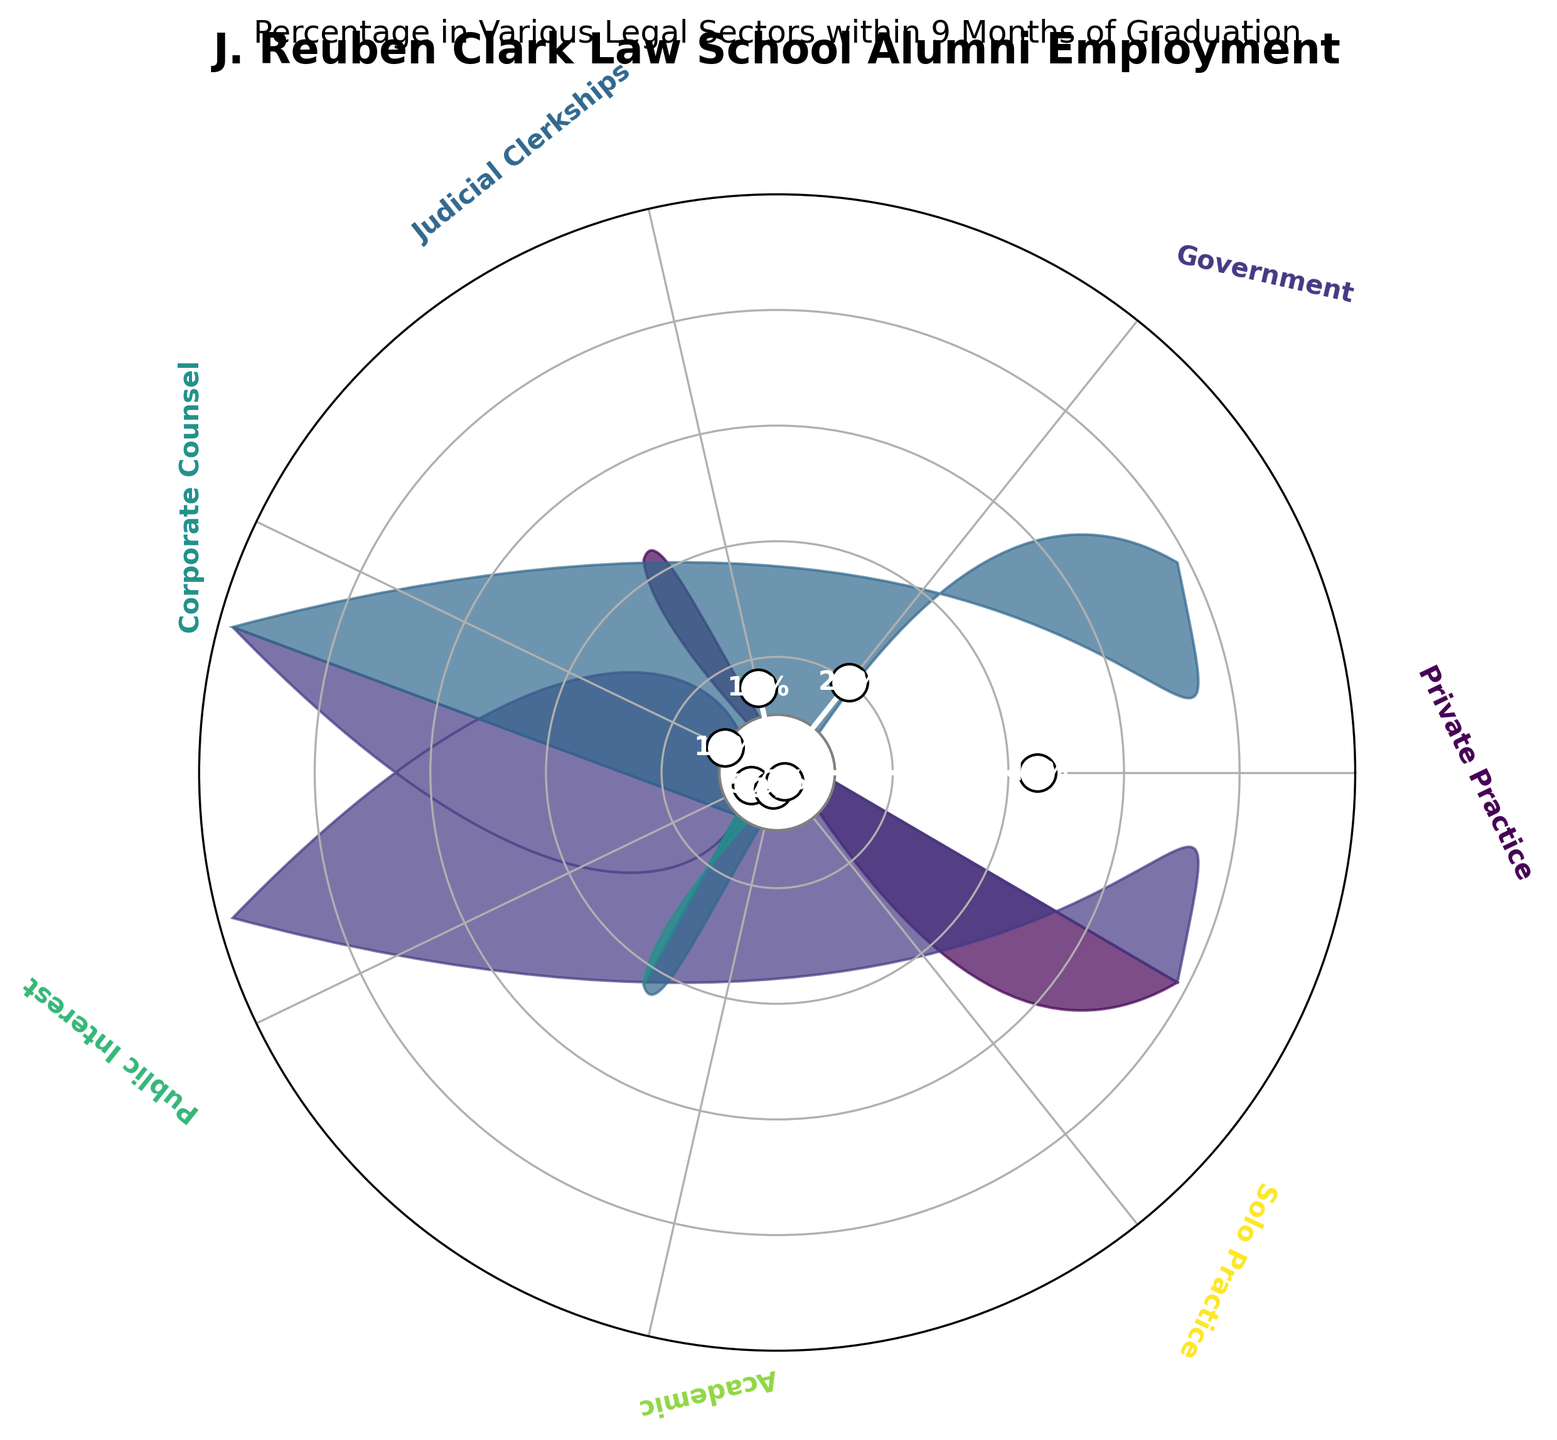What is the title of the chart? The title is generally located at the top of the chart, which reads "J. Reuben Clark Law School Alumni Employment" and the subtitle is "Percentage in Various Legal Sectors within 9 Months of Graduation".
Answer: J. Reuben Clark Law School Alumni Employment Which sector has the highest employment percentage? The sector with the highest percentage will have the longest gauge reaching the furthest out towards 100%.
Answer: Private Practice What is the employment percentage for the Government sector? Locate the Government sector label and check the percentage value labeled at the end of its gauge.
Answer: 20% How many sectors have an employment percentage below 10%? Identify and count all the sectors that have a gauge not reaching the 10% mark.
Answer: 3 Which sector has an employment percentage equal to 15%? Locate the sector gauges and find which one reaches the 15% mark.
Answer: Judicial Clerkships How do the percentages of Public Interest and Corporate Counsel compare? Compare the labeled percentages for Public Interest (5%) and Corporate Counsel (10%).
Answer: Public Interest has a lower percentage than Corporate Counsel What is the combined percentage of alumni employed in Public Interest, Academic, and Solo Practice? Add the percentages of Public Interest (5%), Academic (3%), and Solo Practice (2%).
Answer: 10% Which two sectors together have approximately the same percentage as Government? Find combinations where the sum equals or is close to 20% (e.g., Judicial Clerkships (15%) and Solo Practice (2%) = 17%, or Corporate Counsel (10%) and Public Interest (5%) = 15%).
Answer: Cannot be exact but combinations close to 20% can be Judicial Clerkships and Solo Practice or Corporate Counsel and Public Interest Is the employment percentage for Corporate Counsel greater than that for Public Interest and Academic combined? Compare Corporate Counsel's percentage (10%) with the sum of Public Interest (5%) and Academic (3%) => 5% + 3% = 8%.
Answer: Yes 